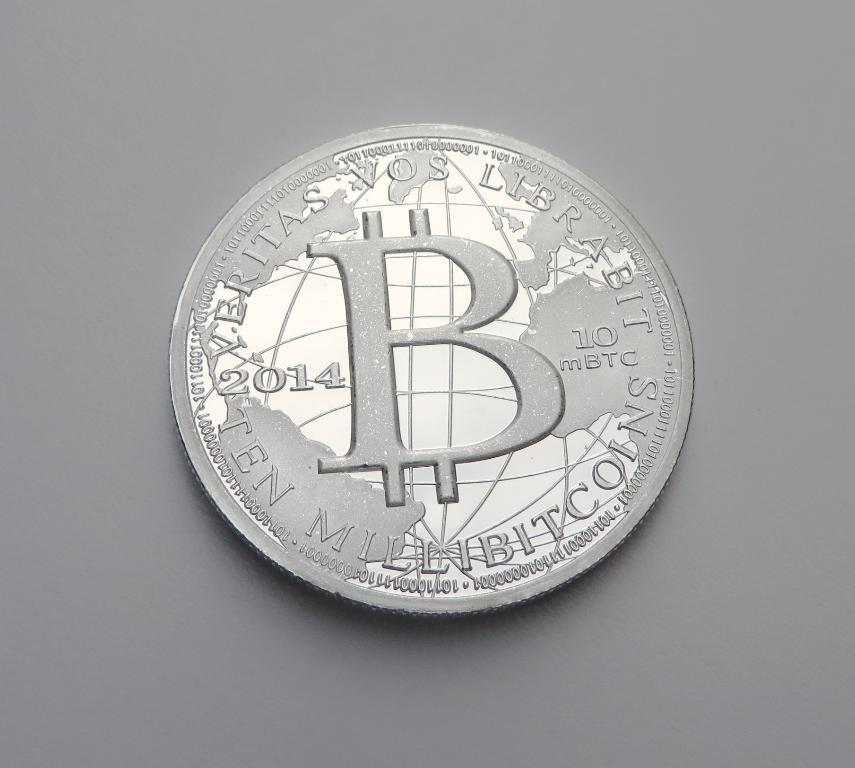What is located on the wall in the image? There is an emblem on the wall in the image. What type of toothbrush is used to make the sound in the image? There is no toothbrush or sound present in the image; it only features an emblem on the wall. 